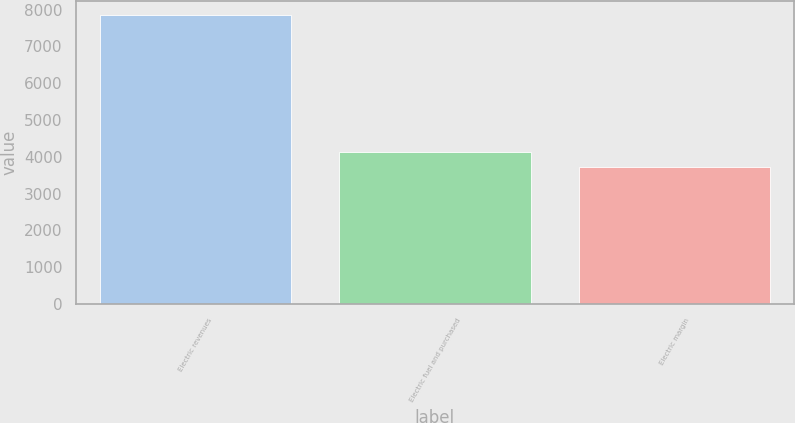Convert chart. <chart><loc_0><loc_0><loc_500><loc_500><bar_chart><fcel>Electric revenues<fcel>Electric fuel and purchased<fcel>Electric margin<nl><fcel>7848<fcel>4137<fcel>3711<nl></chart> 